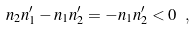Convert formula to latex. <formula><loc_0><loc_0><loc_500><loc_500>n _ { 2 } n ^ { \prime } _ { 1 } - n _ { 1 } n ^ { \prime } _ { 2 } = - n _ { 1 } n ^ { \prime } _ { 2 } < 0 \ ,</formula> 